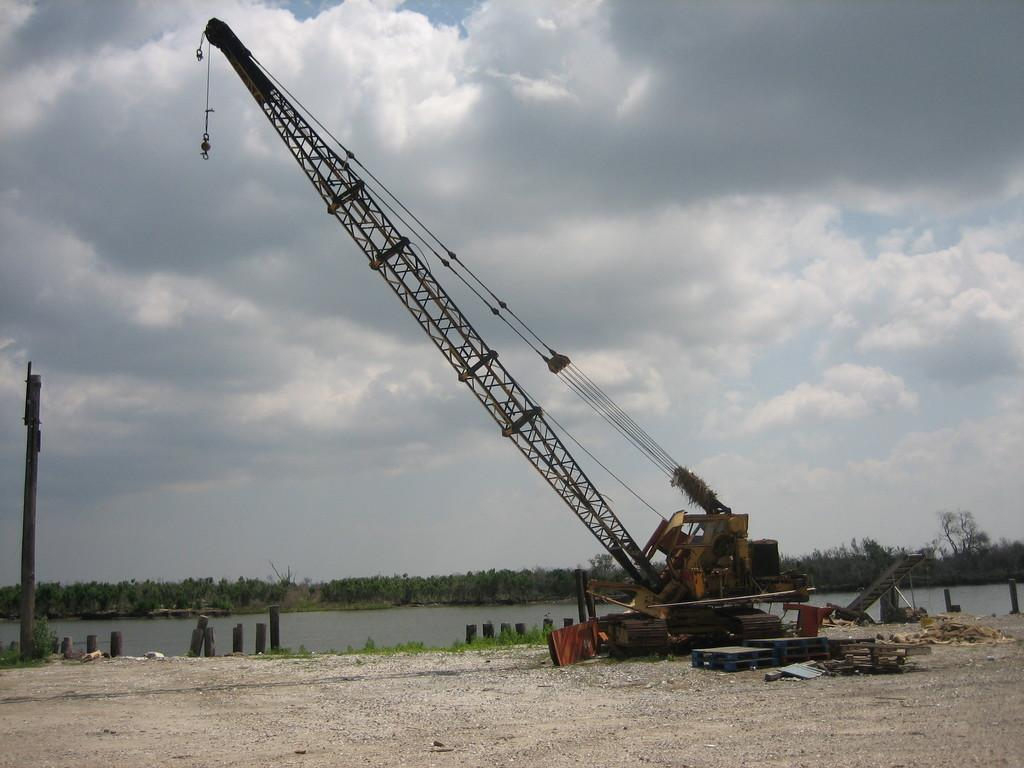What is the main object in the image? There is a crane in the image. What can be seen in the background of the image? There is water and trees visible in the image. How would you describe the sky in the image? The sky is blue and cloudy in the image. What other structures or objects can be seen in the image? There is a pole and wooden planks on the side visible in the image. What time of day is it in the image, and is there a kitten playing in the water? The time of day is not mentioned in the image, and there is no kitten present in the image. 